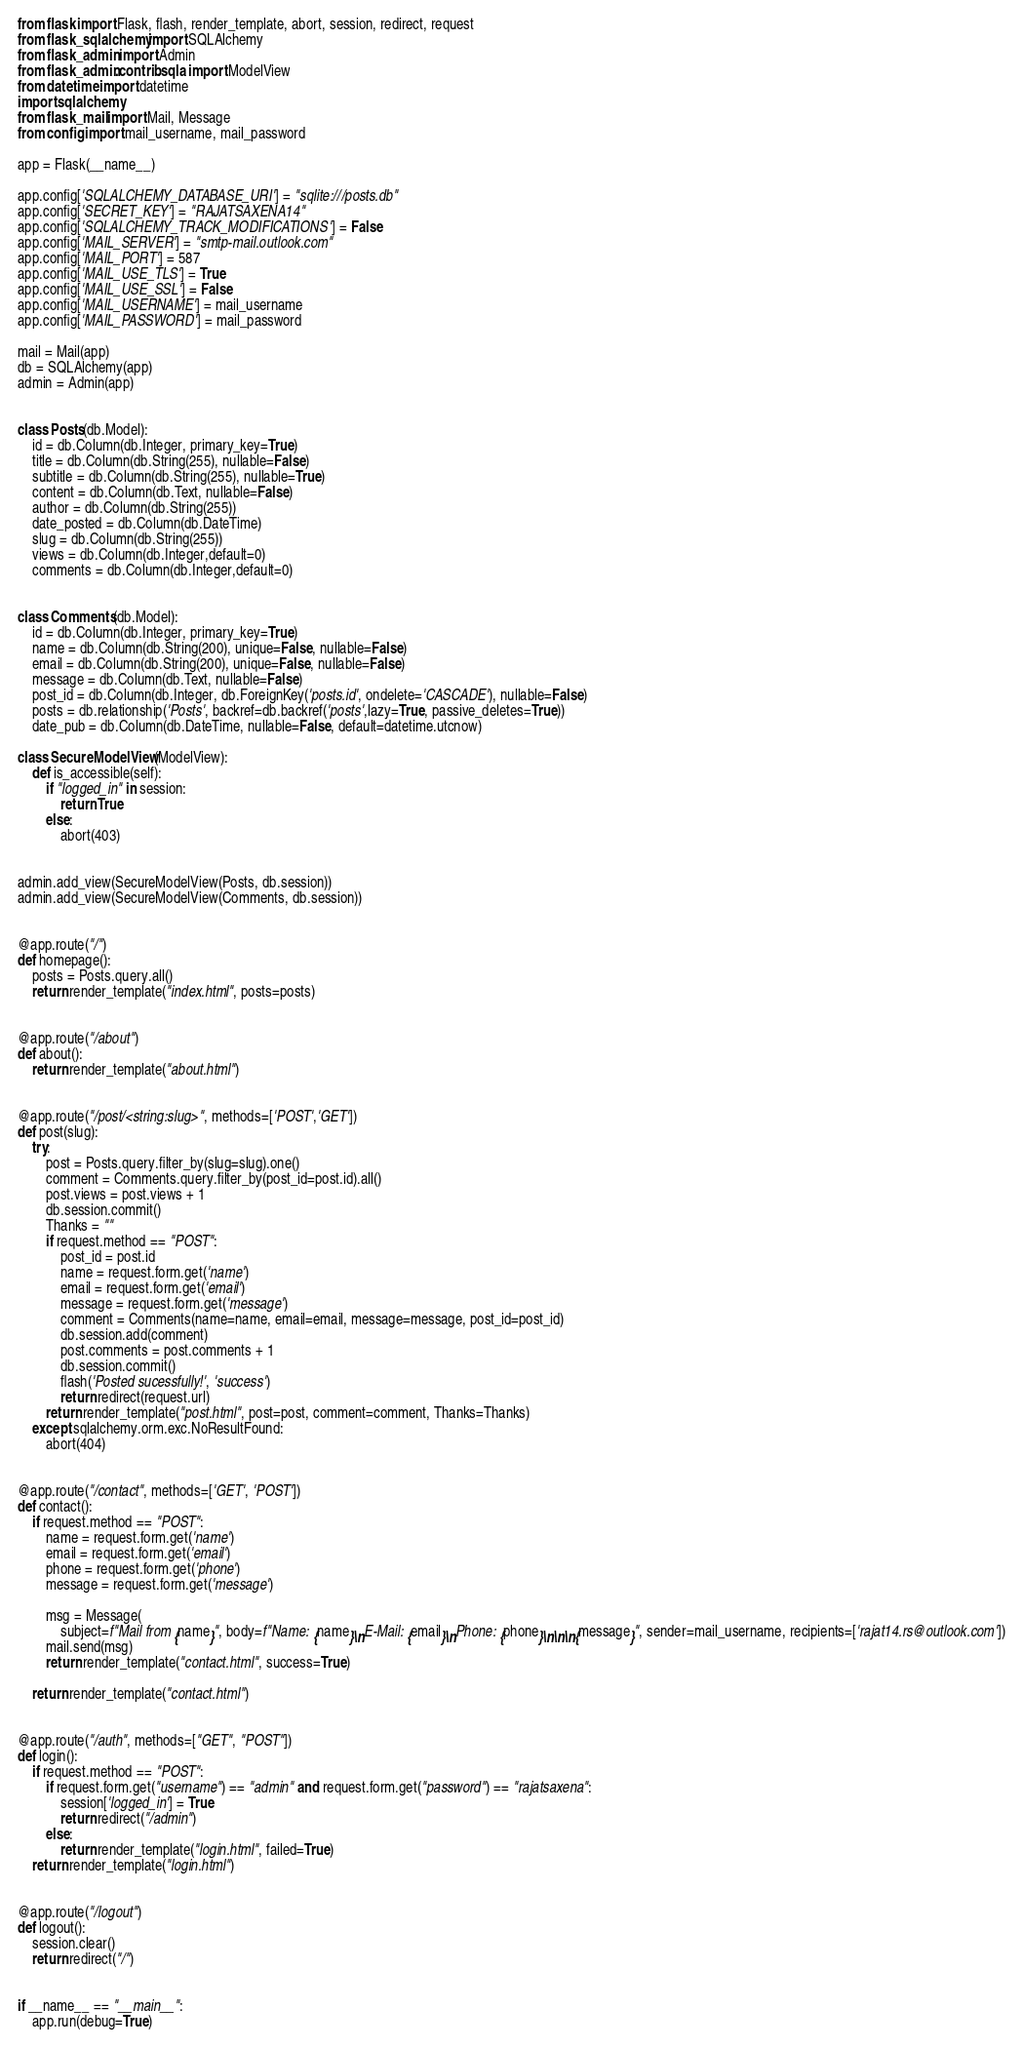<code> <loc_0><loc_0><loc_500><loc_500><_Python_>from flask import Flask, flash, render_template, abort, session, redirect, request
from flask_sqlalchemy import SQLAlchemy
from flask_admin import Admin
from flask_admin.contrib.sqla import ModelView
from datetime import datetime
import sqlalchemy
from flask_mail import Mail, Message
from config import mail_username, mail_password

app = Flask(__name__)

app.config['SQLALCHEMY_DATABASE_URI'] = "sqlite:///posts.db"
app.config['SECRET_KEY'] = "RAJATSAXENA14"
app.config['SQLALCHEMY_TRACK_MODIFICATIONS'] = False
app.config['MAIL_SERVER'] = "smtp-mail.outlook.com"
app.config['MAIL_PORT'] = 587
app.config['MAIL_USE_TLS'] = True
app.config['MAIL_USE_SSL'] = False
app.config['MAIL_USERNAME'] = mail_username
app.config['MAIL_PASSWORD'] = mail_password

mail = Mail(app)
db = SQLAlchemy(app)
admin = Admin(app)


class Posts(db.Model):
    id = db.Column(db.Integer, primary_key=True)
    title = db.Column(db.String(255), nullable=False)
    subtitle = db.Column(db.String(255), nullable=True)
    content = db.Column(db.Text, nullable=False)
    author = db.Column(db.String(255))
    date_posted = db.Column(db.DateTime)
    slug = db.Column(db.String(255))
    views = db.Column(db.Integer,default=0)
    comments = db.Column(db.Integer,default=0)


class Comments(db.Model):
    id = db.Column(db.Integer, primary_key=True)
    name = db.Column(db.String(200), unique=False, nullable=False)
    email = db.Column(db.String(200), unique=False, nullable=False)
    message = db.Column(db.Text, nullable=False)
    post_id = db.Column(db.Integer, db.ForeignKey('posts.id', ondelete='CASCADE'), nullable=False)
    posts = db.relationship('Posts', backref=db.backref('posts',lazy=True, passive_deletes=True))
    date_pub = db.Column(db.DateTime, nullable=False, default=datetime.utcnow)

class SecureModelView(ModelView):
    def is_accessible(self):
        if "logged_in" in session:
            return True
        else:
            abort(403)


admin.add_view(SecureModelView(Posts, db.session))
admin.add_view(SecureModelView(Comments, db.session))


@app.route("/")
def homepage():
    posts = Posts.query.all()
    return render_template("index.html", posts=posts)


@app.route("/about")
def about():
    return render_template("about.html")


@app.route("/post/<string:slug>", methods=['POST','GET'])
def post(slug):
    try:
        post = Posts.query.filter_by(slug=slug).one()
        comment = Comments.query.filter_by(post_id=post.id).all()
        post.views = post.views + 1
        db.session.commit()
        Thanks = ""
        if request.method == "POST":
            post_id = post.id
            name = request.form.get('name')
            email = request.form.get('email')
            message = request.form.get('message')
            comment = Comments(name=name, email=email, message=message, post_id=post_id)
            db.session.add(comment)
            post.comments = post.comments + 1
            db.session.commit()
            flash('Posted sucessfully!', 'success')
            return redirect(request.url)
        return render_template("post.html", post=post, comment=comment, Thanks=Thanks)
    except sqlalchemy.orm.exc.NoResultFound:
        abort(404)


@app.route("/contact", methods=['GET', 'POST'])
def contact():
    if request.method == "POST":
        name = request.form.get('name')
        email = request.form.get('email')
        phone = request.form.get('phone')
        message = request.form.get('message')

        msg = Message(
            subject=f"Mail from {name}", body=f"Name: {name}\nE-Mail: {email}\nPhone: {phone}\n\n\n{message}", sender=mail_username, recipients=['rajat14.rs@outlook.com'])
        mail.send(msg)
        return render_template("contact.html", success=True)

    return render_template("contact.html")


@app.route("/auth", methods=["GET", "POST"])
def login():
    if request.method == "POST":
        if request.form.get("username") == "admin" and request.form.get("password") == "rajatsaxena":
            session['logged_in'] = True
            return redirect("/admin")
        else:
            return render_template("login.html", failed=True)
    return render_template("login.html")


@app.route("/logout")
def logout():
    session.clear()
    return redirect("/")


if __name__ == "__main__":
    app.run(debug=True)
</code> 